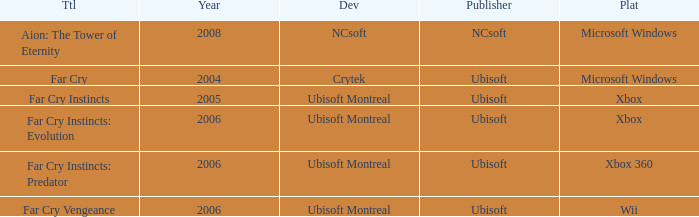Which title has xbox as the platform with a year prior to 2006? Far Cry Instincts. 